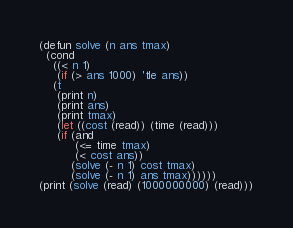Convert code to text. <code><loc_0><loc_0><loc_500><loc_500><_Lisp_>(defun solve (n ans tmax)
  (cond
    ((< n 1)
     (if (> ans 1000) 'tle ans))
    (t
     (print n)
     (print ans)
     (print tmax)
     (let ((cost (read)) (time (read)))
	 (if (and
	      (<= time tmax)
	      (< cost ans))
	     (solve (- n 1) cost tmax)
	     (solve (- n 1) ans tmax))))))
(print (solve (read) (1000000000) (read)))</code> 